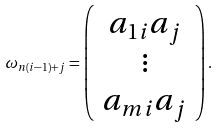Convert formula to latex. <formula><loc_0><loc_0><loc_500><loc_500>\omega _ { n ( i - 1 ) + j } = \left ( \begin{array} { c } a _ { 1 i } a _ { j } \\ \vdots \\ a _ { m i } a _ { j } \end{array} \right ) .</formula> 